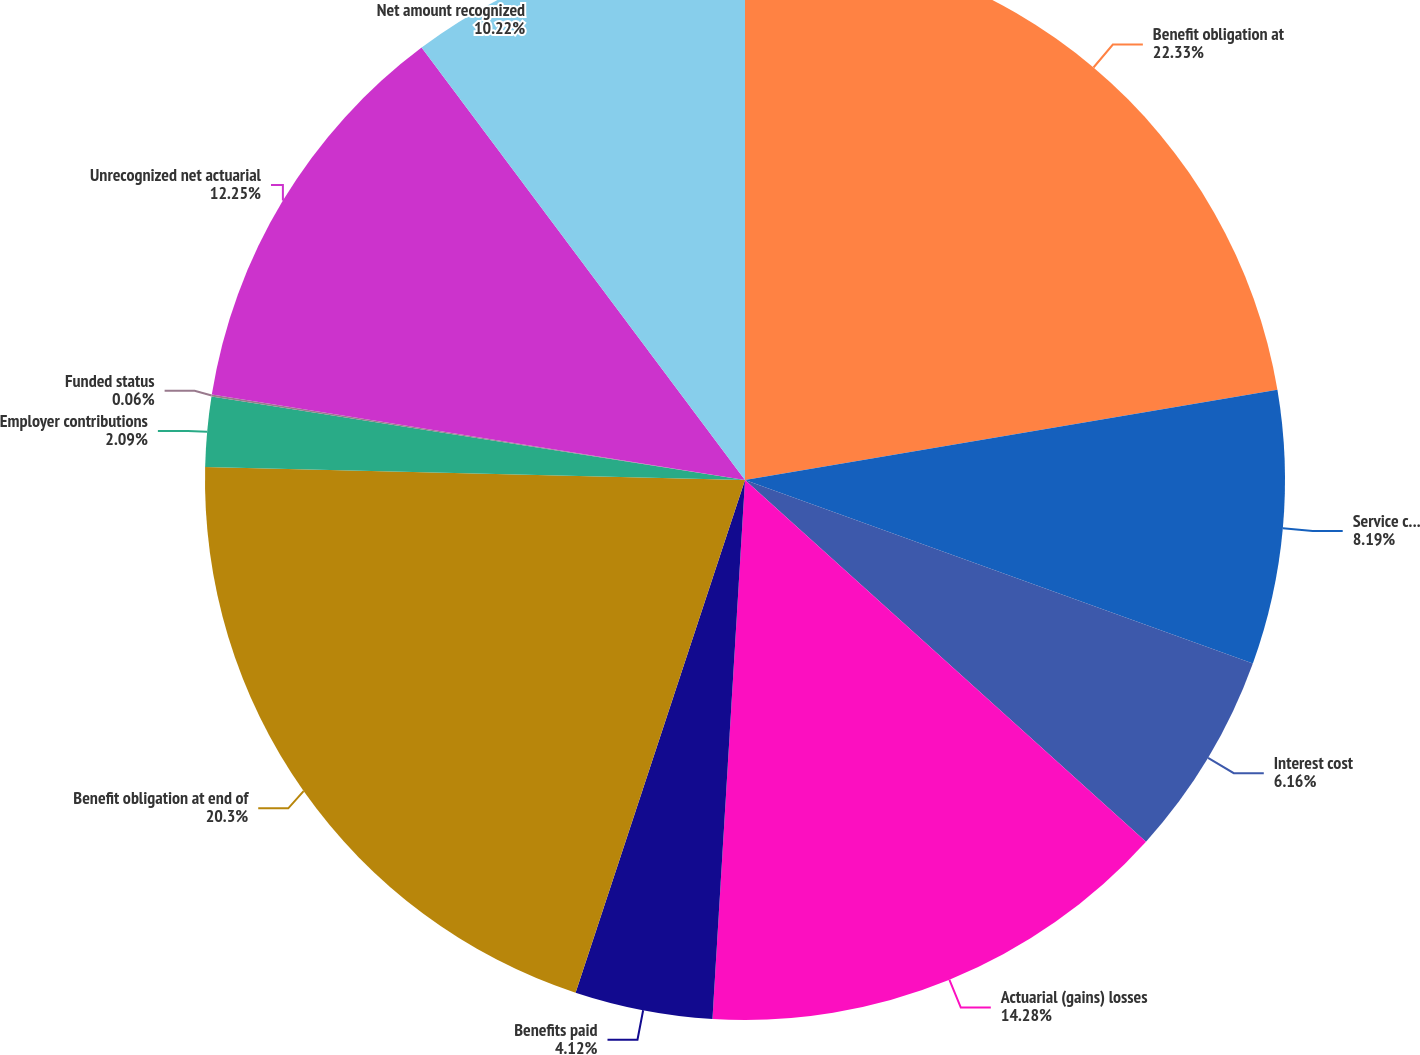Convert chart. <chart><loc_0><loc_0><loc_500><loc_500><pie_chart><fcel>Benefit obligation at<fcel>Service cost gross<fcel>Interest cost<fcel>Actuarial (gains) losses<fcel>Benefits paid<fcel>Benefit obligation at end of<fcel>Employer contributions<fcel>Funded status<fcel>Unrecognized net actuarial<fcel>Net amount recognized<nl><fcel>22.33%<fcel>8.19%<fcel>6.16%<fcel>14.28%<fcel>4.12%<fcel>20.3%<fcel>2.09%<fcel>0.06%<fcel>12.25%<fcel>10.22%<nl></chart> 